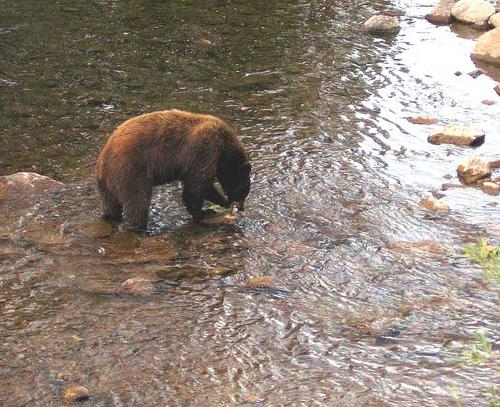Question: what is the bear standing in?
Choices:
A. Grass.
B. Mud.
C. Water.
D. A hole in the ground.
Answer with the letter. Answer: C Question: who is in the water eating?
Choices:
A. A boy.
B. A fisherman.
C. A bear.
D. A surfer.
Answer with the letter. Answer: C Question: why is he leaning in the water?
Choices:
A. Looking at his reflection.
B. Checking the flow of the water.
C. Picking up his fishing rod.
D. Looking for fish.
Answer with the letter. Answer: D 